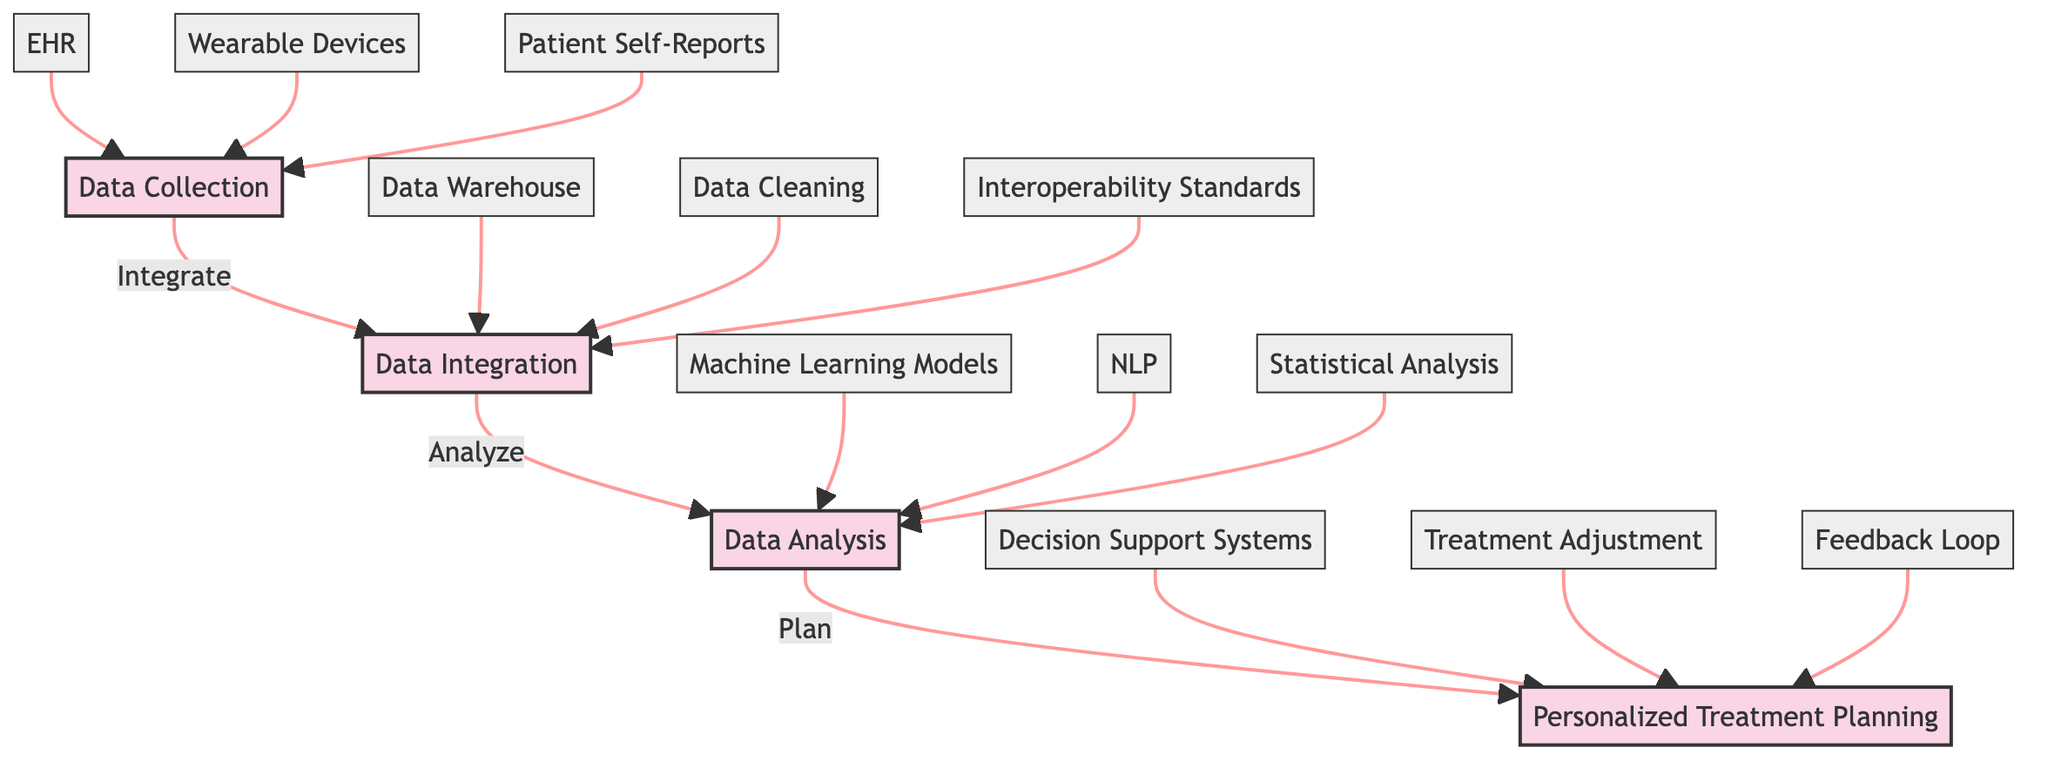What are the stages in the clinical pathway? The stages are sequentially connected in the diagram, showing the flow from Data Collection to Personalized Treatment Planning. The stages are: Data Collection, Data Integration, Data Analysis, and Personalized Treatment Planning.
Answer: Data Collection, Data Integration, Data Analysis, Personalized Treatment Planning How many elements are there in the Data Collection stage? The Data Collection stage lists three distinct elements: EHR, Wearable Devices, and Patient Self-Reports. By counting them, we find there are three elements.
Answer: 3 Which stage comes before Data Analysis? The diagram illustrates a directional flow from Data Integration directly to Data Analysis. Therefore, Data Integration is the stage prior to Data Analysis.
Answer: Data Integration What element in the Data Analysis stage utilizes machine learning? The element labeled Machine Learning Models is specifically mentioned in the Data Analysis stage as utilizing machine learning to predict patient outcomes.
Answer: Machine Learning Models What two elements contribute to the Data Integration stage? The diagram shows that the Data Integration stage consists of three elements, among which Data Warehouse and Data Cleaning are specifically named, contributing to the integration processes.
Answer: Data Warehouse, Data Cleaning Which computational tool is used for extracting information from text in the Data Analysis stage? The diagram identifies Natural Language Processing (NLP) as the computational tool for extracting useful information from unstructured text, illustrating its role in the Data Analysis stage.
Answer: NLP In Personalized Treatment Planning, which element involves ongoing monitoring? The element labeled Feedback Loop in the Personalized Treatment Planning stage emphasizes the importance of continuous monitoring and reassessment of treatment plans.
Answer: Feedback Loop What is the primary purpose of Decision Support Systems in the pathway? According to the diagram, Decision Support Systems provide evidence-based recommendations, serving as a critical tool in designing tailored psychological treatments for patients.
Answer: Evidence-based recommendations How does the Data Collection stage facilitate personalized treatment? The Data Collection stage gathers individual-specific data from various sources (EHR, Wearable Devices, and Patient Self-Reports), creating a foundation for personalized care and treatment plans downstream.
Answer: By gathering individual-specific data 